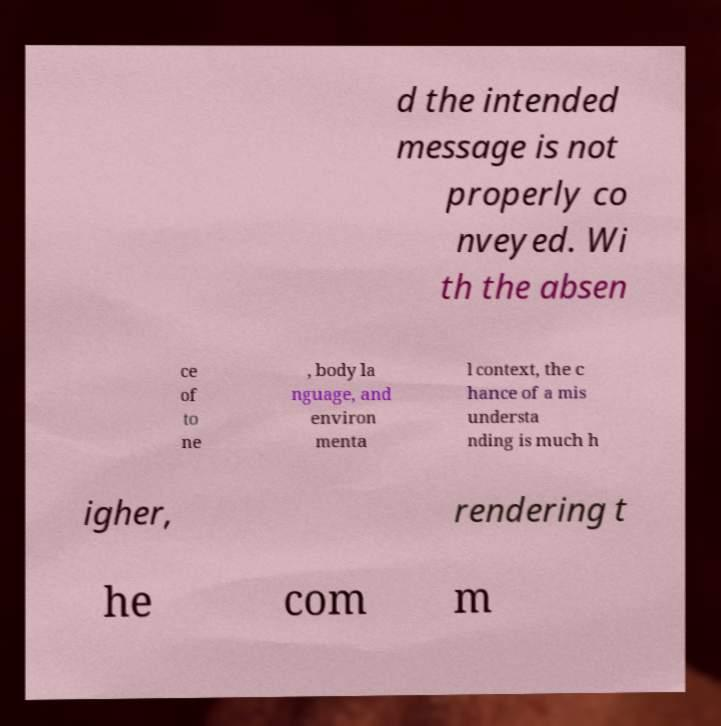Can you accurately transcribe the text from the provided image for me? d the intended message is not properly co nveyed. Wi th the absen ce of to ne , body la nguage, and environ menta l context, the c hance of a mis understa nding is much h igher, rendering t he com m 